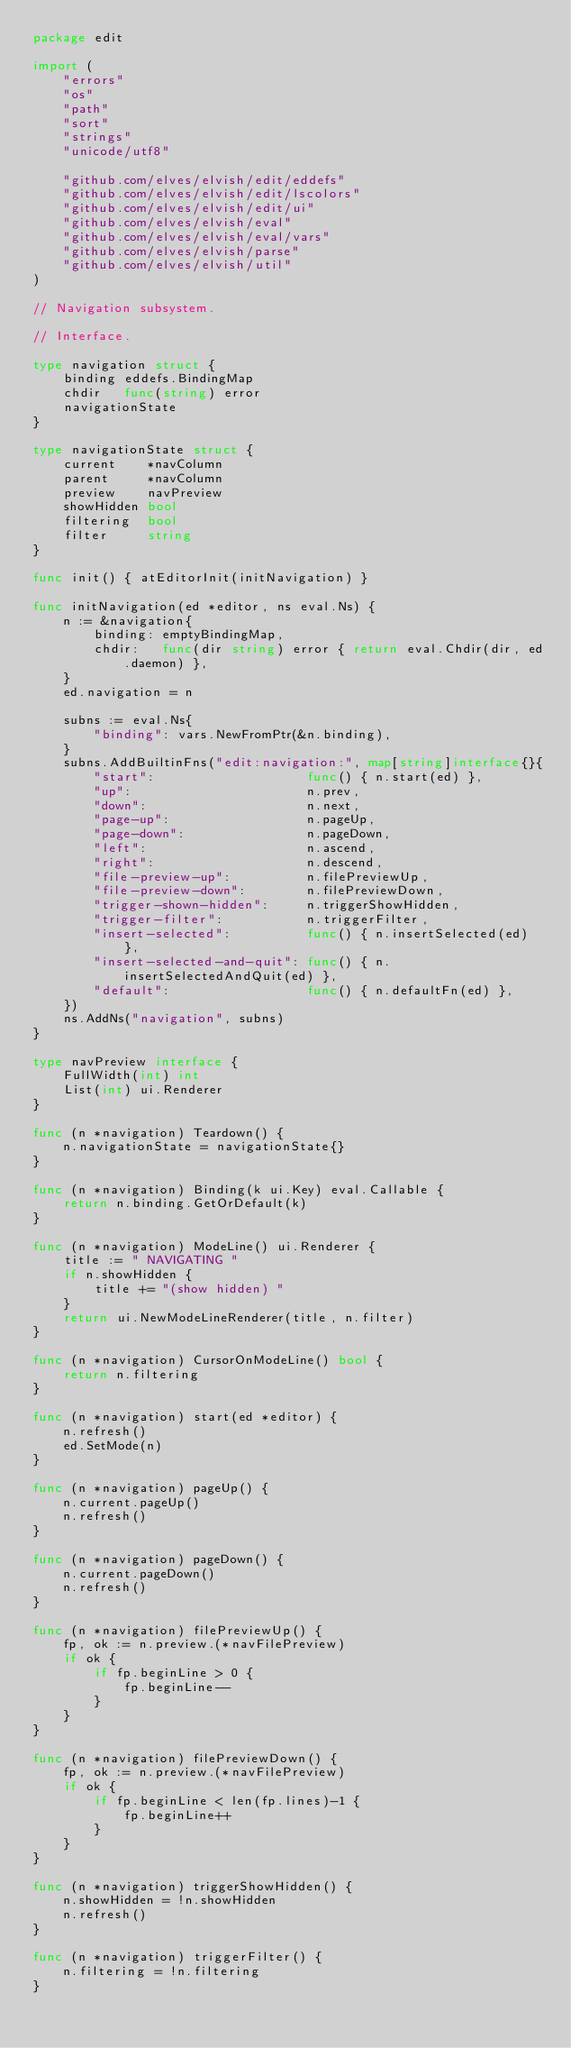<code> <loc_0><loc_0><loc_500><loc_500><_Go_>package edit

import (
	"errors"
	"os"
	"path"
	"sort"
	"strings"
	"unicode/utf8"

	"github.com/elves/elvish/edit/eddefs"
	"github.com/elves/elvish/edit/lscolors"
	"github.com/elves/elvish/edit/ui"
	"github.com/elves/elvish/eval"
	"github.com/elves/elvish/eval/vars"
	"github.com/elves/elvish/parse"
	"github.com/elves/elvish/util"
)

// Navigation subsystem.

// Interface.

type navigation struct {
	binding eddefs.BindingMap
	chdir   func(string) error
	navigationState
}

type navigationState struct {
	current    *navColumn
	parent     *navColumn
	preview    navPreview
	showHidden bool
	filtering  bool
	filter     string
}

func init() { atEditorInit(initNavigation) }

func initNavigation(ed *editor, ns eval.Ns) {
	n := &navigation{
		binding: emptyBindingMap,
		chdir:   func(dir string) error { return eval.Chdir(dir, ed.daemon) },
	}
	ed.navigation = n

	subns := eval.Ns{
		"binding": vars.NewFromPtr(&n.binding),
	}
	subns.AddBuiltinFns("edit:navigation:", map[string]interface{}{
		"start":                    func() { n.start(ed) },
		"up":                       n.prev,
		"down":                     n.next,
		"page-up":                  n.pageUp,
		"page-down":                n.pageDown,
		"left":                     n.ascend,
		"right":                    n.descend,
		"file-preview-up":          n.filePreviewUp,
		"file-preview-down":        n.filePreviewDown,
		"trigger-shown-hidden":     n.triggerShowHidden,
		"trigger-filter":           n.triggerFilter,
		"insert-selected":          func() { n.insertSelected(ed) },
		"insert-selected-and-quit": func() { n.insertSelectedAndQuit(ed) },
		"default":                  func() { n.defaultFn(ed) },
	})
	ns.AddNs("navigation", subns)
}

type navPreview interface {
	FullWidth(int) int
	List(int) ui.Renderer
}

func (n *navigation) Teardown() {
	n.navigationState = navigationState{}
}

func (n *navigation) Binding(k ui.Key) eval.Callable {
	return n.binding.GetOrDefault(k)
}

func (n *navigation) ModeLine() ui.Renderer {
	title := " NAVIGATING "
	if n.showHidden {
		title += "(show hidden) "
	}
	return ui.NewModeLineRenderer(title, n.filter)
}

func (n *navigation) CursorOnModeLine() bool {
	return n.filtering
}

func (n *navigation) start(ed *editor) {
	n.refresh()
	ed.SetMode(n)
}

func (n *navigation) pageUp() {
	n.current.pageUp()
	n.refresh()
}

func (n *navigation) pageDown() {
	n.current.pageDown()
	n.refresh()
}

func (n *navigation) filePreviewUp() {
	fp, ok := n.preview.(*navFilePreview)
	if ok {
		if fp.beginLine > 0 {
			fp.beginLine--
		}
	}
}

func (n *navigation) filePreviewDown() {
	fp, ok := n.preview.(*navFilePreview)
	if ok {
		if fp.beginLine < len(fp.lines)-1 {
			fp.beginLine++
		}
	}
}

func (n *navigation) triggerShowHidden() {
	n.showHidden = !n.showHidden
	n.refresh()
}

func (n *navigation) triggerFilter() {
	n.filtering = !n.filtering
}
</code> 